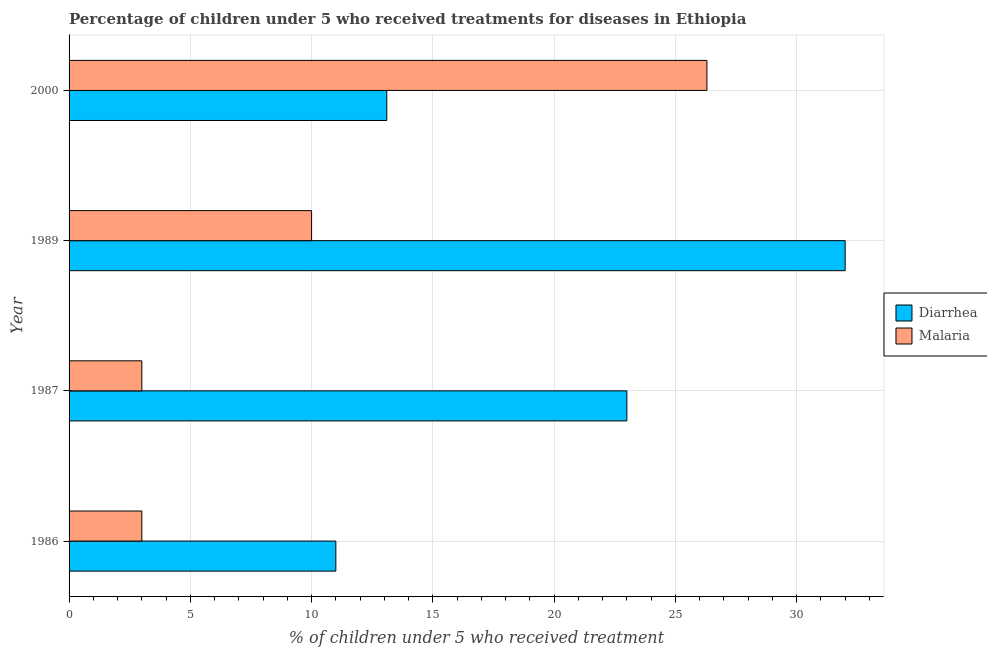How many different coloured bars are there?
Ensure brevity in your answer.  2. How many groups of bars are there?
Make the answer very short. 4. What is the label of the 2nd group of bars from the top?
Offer a very short reply. 1989. What is the percentage of children who received treatment for malaria in 1989?
Provide a short and direct response. 10. Across all years, what is the maximum percentage of children who received treatment for diarrhoea?
Your answer should be very brief. 32. Across all years, what is the minimum percentage of children who received treatment for diarrhoea?
Keep it short and to the point. 11. In which year was the percentage of children who received treatment for malaria maximum?
Provide a short and direct response. 2000. In which year was the percentage of children who received treatment for diarrhoea minimum?
Provide a short and direct response. 1986. What is the total percentage of children who received treatment for malaria in the graph?
Your response must be concise. 42.3. What is the difference between the percentage of children who received treatment for diarrhoea in 1987 and the percentage of children who received treatment for malaria in 1986?
Offer a very short reply. 20. What is the average percentage of children who received treatment for diarrhoea per year?
Your answer should be very brief. 19.77. In how many years, is the percentage of children who received treatment for malaria greater than 24 %?
Give a very brief answer. 1. What is the ratio of the percentage of children who received treatment for malaria in 1986 to that in 2000?
Your response must be concise. 0.11. Is the difference between the percentage of children who received treatment for diarrhoea in 1986 and 1987 greater than the difference between the percentage of children who received treatment for malaria in 1986 and 1987?
Ensure brevity in your answer.  No. What is the difference between the highest and the lowest percentage of children who received treatment for diarrhoea?
Provide a succinct answer. 21. In how many years, is the percentage of children who received treatment for diarrhoea greater than the average percentage of children who received treatment for diarrhoea taken over all years?
Offer a terse response. 2. Is the sum of the percentage of children who received treatment for malaria in 1986 and 2000 greater than the maximum percentage of children who received treatment for diarrhoea across all years?
Your response must be concise. No. What does the 2nd bar from the top in 1987 represents?
Ensure brevity in your answer.  Diarrhea. What does the 2nd bar from the bottom in 1986 represents?
Offer a very short reply. Malaria. How many bars are there?
Offer a terse response. 8. How many years are there in the graph?
Your answer should be very brief. 4. Are the values on the major ticks of X-axis written in scientific E-notation?
Your answer should be very brief. No. Does the graph contain any zero values?
Your answer should be compact. No. Does the graph contain grids?
Give a very brief answer. Yes. Where does the legend appear in the graph?
Give a very brief answer. Center right. How many legend labels are there?
Offer a very short reply. 2. How are the legend labels stacked?
Your answer should be very brief. Vertical. What is the title of the graph?
Your response must be concise. Percentage of children under 5 who received treatments for diseases in Ethiopia. Does "Fixed telephone" appear as one of the legend labels in the graph?
Provide a succinct answer. No. What is the label or title of the X-axis?
Offer a very short reply. % of children under 5 who received treatment. What is the % of children under 5 who received treatment of Diarrhea in 1987?
Give a very brief answer. 23. What is the % of children under 5 who received treatment of Malaria in 1987?
Give a very brief answer. 3. What is the % of children under 5 who received treatment in Malaria in 1989?
Give a very brief answer. 10. What is the % of children under 5 who received treatment in Malaria in 2000?
Give a very brief answer. 26.3. Across all years, what is the maximum % of children under 5 who received treatment of Malaria?
Ensure brevity in your answer.  26.3. What is the total % of children under 5 who received treatment of Diarrhea in the graph?
Offer a very short reply. 79.1. What is the total % of children under 5 who received treatment of Malaria in the graph?
Give a very brief answer. 42.3. What is the difference between the % of children under 5 who received treatment of Diarrhea in 1986 and that in 1987?
Keep it short and to the point. -12. What is the difference between the % of children under 5 who received treatment of Malaria in 1986 and that in 1987?
Give a very brief answer. 0. What is the difference between the % of children under 5 who received treatment in Diarrhea in 1986 and that in 2000?
Make the answer very short. -2.1. What is the difference between the % of children under 5 who received treatment of Malaria in 1986 and that in 2000?
Offer a terse response. -23.3. What is the difference between the % of children under 5 who received treatment in Malaria in 1987 and that in 2000?
Your response must be concise. -23.3. What is the difference between the % of children under 5 who received treatment of Malaria in 1989 and that in 2000?
Ensure brevity in your answer.  -16.3. What is the difference between the % of children under 5 who received treatment of Diarrhea in 1986 and the % of children under 5 who received treatment of Malaria in 1987?
Your answer should be very brief. 8. What is the difference between the % of children under 5 who received treatment in Diarrhea in 1986 and the % of children under 5 who received treatment in Malaria in 2000?
Keep it short and to the point. -15.3. What is the difference between the % of children under 5 who received treatment in Diarrhea in 1987 and the % of children under 5 who received treatment in Malaria in 1989?
Keep it short and to the point. 13. What is the difference between the % of children under 5 who received treatment of Diarrhea in 1987 and the % of children under 5 who received treatment of Malaria in 2000?
Provide a short and direct response. -3.3. What is the average % of children under 5 who received treatment in Diarrhea per year?
Your answer should be very brief. 19.77. What is the average % of children under 5 who received treatment in Malaria per year?
Ensure brevity in your answer.  10.57. In the year 1987, what is the difference between the % of children under 5 who received treatment in Diarrhea and % of children under 5 who received treatment in Malaria?
Make the answer very short. 20. In the year 1989, what is the difference between the % of children under 5 who received treatment in Diarrhea and % of children under 5 who received treatment in Malaria?
Your answer should be very brief. 22. What is the ratio of the % of children under 5 who received treatment in Diarrhea in 1986 to that in 1987?
Keep it short and to the point. 0.48. What is the ratio of the % of children under 5 who received treatment of Malaria in 1986 to that in 1987?
Your answer should be compact. 1. What is the ratio of the % of children under 5 who received treatment of Diarrhea in 1986 to that in 1989?
Keep it short and to the point. 0.34. What is the ratio of the % of children under 5 who received treatment of Malaria in 1986 to that in 1989?
Your answer should be compact. 0.3. What is the ratio of the % of children under 5 who received treatment in Diarrhea in 1986 to that in 2000?
Offer a very short reply. 0.84. What is the ratio of the % of children under 5 who received treatment of Malaria in 1986 to that in 2000?
Give a very brief answer. 0.11. What is the ratio of the % of children under 5 who received treatment of Diarrhea in 1987 to that in 1989?
Keep it short and to the point. 0.72. What is the ratio of the % of children under 5 who received treatment of Diarrhea in 1987 to that in 2000?
Offer a terse response. 1.76. What is the ratio of the % of children under 5 who received treatment in Malaria in 1987 to that in 2000?
Provide a succinct answer. 0.11. What is the ratio of the % of children under 5 who received treatment of Diarrhea in 1989 to that in 2000?
Your answer should be compact. 2.44. What is the ratio of the % of children under 5 who received treatment in Malaria in 1989 to that in 2000?
Make the answer very short. 0.38. What is the difference between the highest and the second highest % of children under 5 who received treatment of Diarrhea?
Offer a terse response. 9. What is the difference between the highest and the lowest % of children under 5 who received treatment of Diarrhea?
Provide a short and direct response. 21. What is the difference between the highest and the lowest % of children under 5 who received treatment of Malaria?
Your response must be concise. 23.3. 